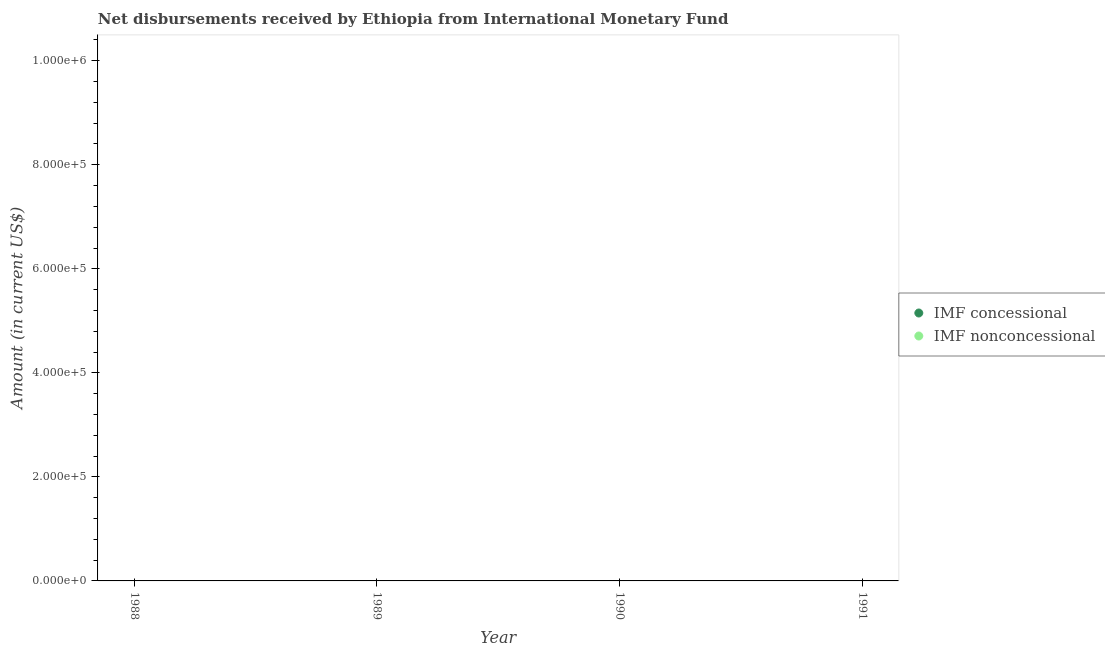How many different coloured dotlines are there?
Provide a short and direct response. 0. Is the number of dotlines equal to the number of legend labels?
Make the answer very short. No. What is the net concessional disbursements from imf in 1991?
Your answer should be compact. 0. Across all years, what is the minimum net non concessional disbursements from imf?
Ensure brevity in your answer.  0. What is the total net non concessional disbursements from imf in the graph?
Your answer should be very brief. 0. What is the average net non concessional disbursements from imf per year?
Offer a very short reply. 0. Is the net non concessional disbursements from imf strictly less than the net concessional disbursements from imf over the years?
Give a very brief answer. Yes. What is the difference between two consecutive major ticks on the Y-axis?
Your answer should be compact. 2.00e+05. Does the graph contain any zero values?
Your answer should be compact. Yes. How are the legend labels stacked?
Provide a short and direct response. Vertical. What is the title of the graph?
Keep it short and to the point. Net disbursements received by Ethiopia from International Monetary Fund. What is the Amount (in current US$) of IMF nonconcessional in 1988?
Offer a terse response. 0. What is the Amount (in current US$) of IMF concessional in 1990?
Your response must be concise. 0. What is the Amount (in current US$) in IMF nonconcessional in 1991?
Your response must be concise. 0. What is the total Amount (in current US$) of IMF concessional in the graph?
Make the answer very short. 0. What is the total Amount (in current US$) of IMF nonconcessional in the graph?
Keep it short and to the point. 0. 